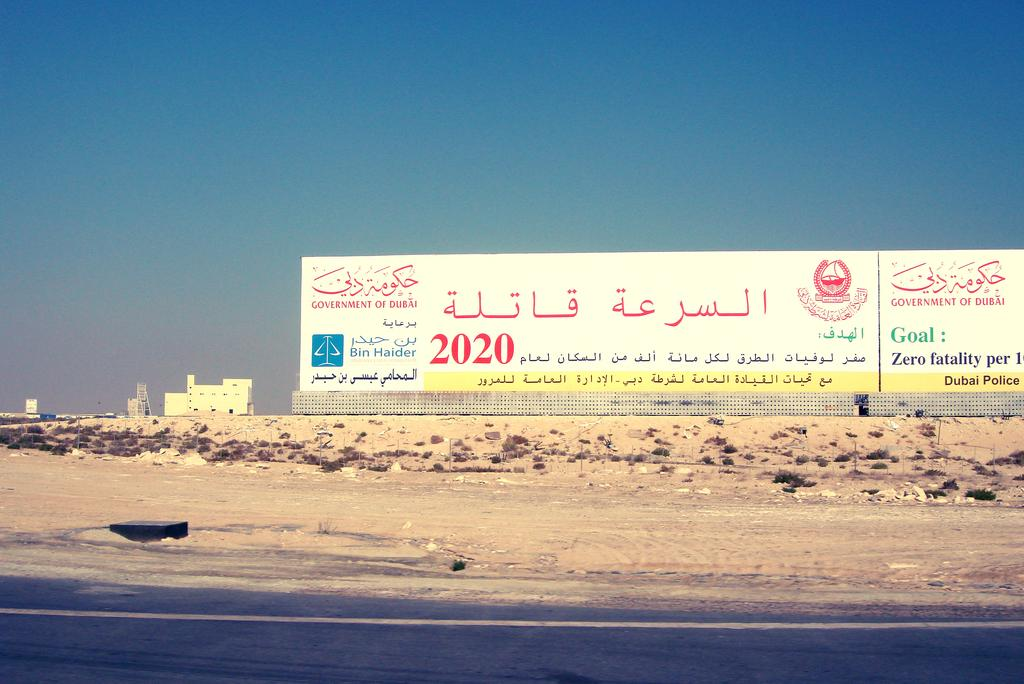Provide a one-sentence caption for the provided image. A sign in Arabic with the name Bin Haider sits on dry soil by the road. 